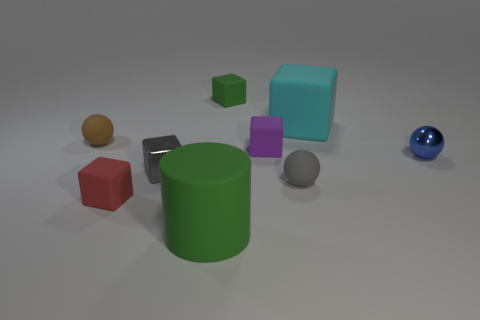Subtract all red cubes. How many cubes are left? 4 Subtract all tiny red blocks. How many blocks are left? 4 Subtract all yellow blocks. Subtract all purple balls. How many blocks are left? 5 Add 1 small gray objects. How many objects exist? 10 Subtract all cubes. How many objects are left? 4 Subtract 0 red cylinders. How many objects are left? 9 Subtract all large green cylinders. Subtract all small gray spheres. How many objects are left? 7 Add 5 large green cylinders. How many large green cylinders are left? 6 Add 6 small gray spheres. How many small gray spheres exist? 7 